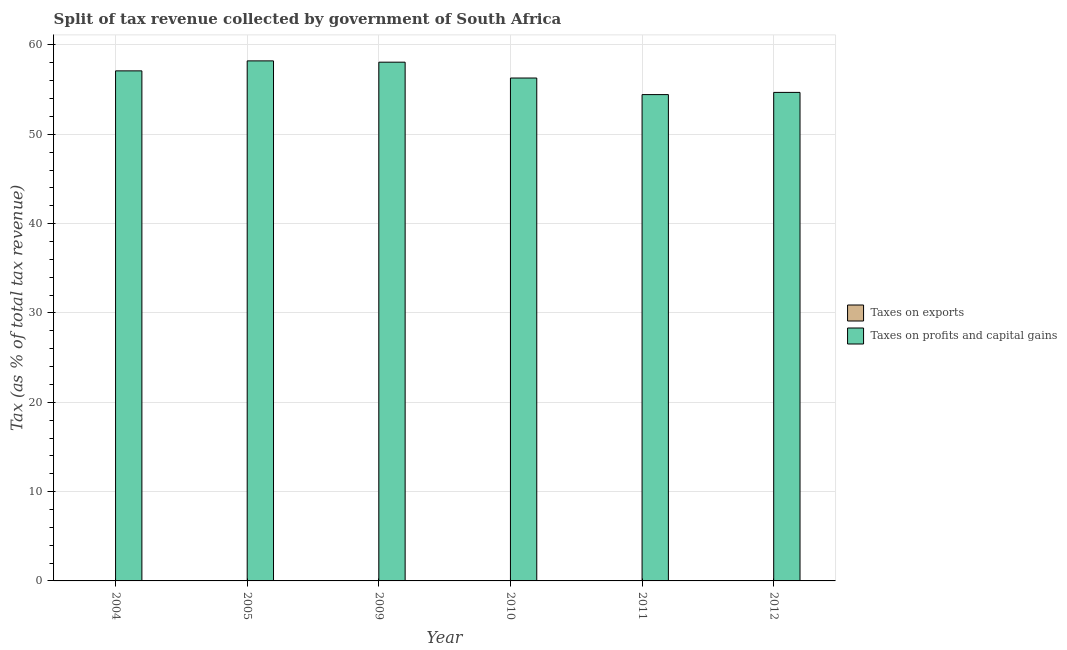How many different coloured bars are there?
Your response must be concise. 2. Are the number of bars per tick equal to the number of legend labels?
Your answer should be compact. Yes. Are the number of bars on each tick of the X-axis equal?
Your response must be concise. Yes. How many bars are there on the 2nd tick from the right?
Your response must be concise. 2. In how many cases, is the number of bars for a given year not equal to the number of legend labels?
Give a very brief answer. 0. What is the percentage of revenue obtained from taxes on profits and capital gains in 2010?
Provide a short and direct response. 56.3. Across all years, what is the maximum percentage of revenue obtained from taxes on profits and capital gains?
Give a very brief answer. 58.22. Across all years, what is the minimum percentage of revenue obtained from taxes on profits and capital gains?
Make the answer very short. 54.45. In which year was the percentage of revenue obtained from taxes on profits and capital gains maximum?
Your response must be concise. 2005. What is the total percentage of revenue obtained from taxes on exports in the graph?
Provide a succinct answer. 0.03. What is the difference between the percentage of revenue obtained from taxes on exports in 2004 and that in 2012?
Ensure brevity in your answer.  -0.01. What is the difference between the percentage of revenue obtained from taxes on profits and capital gains in 2012 and the percentage of revenue obtained from taxes on exports in 2010?
Keep it short and to the point. -1.61. What is the average percentage of revenue obtained from taxes on profits and capital gains per year?
Make the answer very short. 56.47. What is the ratio of the percentage of revenue obtained from taxes on profits and capital gains in 2009 to that in 2010?
Your answer should be compact. 1.03. What is the difference between the highest and the second highest percentage of revenue obtained from taxes on profits and capital gains?
Your response must be concise. 0.15. What is the difference between the highest and the lowest percentage of revenue obtained from taxes on exports?
Give a very brief answer. 0.01. In how many years, is the percentage of revenue obtained from taxes on exports greater than the average percentage of revenue obtained from taxes on exports taken over all years?
Your answer should be very brief. 4. What does the 1st bar from the left in 2009 represents?
Give a very brief answer. Taxes on exports. What does the 2nd bar from the right in 2004 represents?
Offer a terse response. Taxes on exports. How many years are there in the graph?
Provide a short and direct response. 6. What is the difference between two consecutive major ticks on the Y-axis?
Keep it short and to the point. 10. Does the graph contain any zero values?
Provide a short and direct response. No. Does the graph contain grids?
Your answer should be compact. Yes. How are the legend labels stacked?
Your answer should be compact. Vertical. What is the title of the graph?
Keep it short and to the point. Split of tax revenue collected by government of South Africa. What is the label or title of the Y-axis?
Offer a terse response. Tax (as % of total tax revenue). What is the Tax (as % of total tax revenue) of Taxes on exports in 2004?
Provide a succinct answer. 0. What is the Tax (as % of total tax revenue) of Taxes on profits and capital gains in 2004?
Offer a terse response. 57.1. What is the Tax (as % of total tax revenue) of Taxes on exports in 2005?
Offer a terse response. 0. What is the Tax (as % of total tax revenue) of Taxes on profits and capital gains in 2005?
Provide a short and direct response. 58.22. What is the Tax (as % of total tax revenue) of Taxes on exports in 2009?
Provide a succinct answer. 0.01. What is the Tax (as % of total tax revenue) of Taxes on profits and capital gains in 2009?
Ensure brevity in your answer.  58.08. What is the Tax (as % of total tax revenue) in Taxes on exports in 2010?
Your response must be concise. 0.01. What is the Tax (as % of total tax revenue) in Taxes on profits and capital gains in 2010?
Provide a short and direct response. 56.3. What is the Tax (as % of total tax revenue) of Taxes on exports in 2011?
Offer a very short reply. 0.01. What is the Tax (as % of total tax revenue) in Taxes on profits and capital gains in 2011?
Give a very brief answer. 54.45. What is the Tax (as % of total tax revenue) of Taxes on exports in 2012?
Your answer should be very brief. 0.01. What is the Tax (as % of total tax revenue) of Taxes on profits and capital gains in 2012?
Provide a short and direct response. 54.69. Across all years, what is the maximum Tax (as % of total tax revenue) of Taxes on exports?
Make the answer very short. 0.01. Across all years, what is the maximum Tax (as % of total tax revenue) of Taxes on profits and capital gains?
Provide a short and direct response. 58.22. Across all years, what is the minimum Tax (as % of total tax revenue) of Taxes on exports?
Your answer should be very brief. 0. Across all years, what is the minimum Tax (as % of total tax revenue) in Taxes on profits and capital gains?
Ensure brevity in your answer.  54.45. What is the total Tax (as % of total tax revenue) of Taxes on exports in the graph?
Your response must be concise. 0.03. What is the total Tax (as % of total tax revenue) in Taxes on profits and capital gains in the graph?
Ensure brevity in your answer.  338.84. What is the difference between the Tax (as % of total tax revenue) in Taxes on exports in 2004 and that in 2005?
Your response must be concise. 0. What is the difference between the Tax (as % of total tax revenue) in Taxes on profits and capital gains in 2004 and that in 2005?
Offer a very short reply. -1.12. What is the difference between the Tax (as % of total tax revenue) of Taxes on exports in 2004 and that in 2009?
Your answer should be very brief. -0.01. What is the difference between the Tax (as % of total tax revenue) of Taxes on profits and capital gains in 2004 and that in 2009?
Offer a very short reply. -0.97. What is the difference between the Tax (as % of total tax revenue) in Taxes on exports in 2004 and that in 2010?
Provide a succinct answer. -0.01. What is the difference between the Tax (as % of total tax revenue) in Taxes on profits and capital gains in 2004 and that in 2010?
Make the answer very short. 0.8. What is the difference between the Tax (as % of total tax revenue) of Taxes on exports in 2004 and that in 2011?
Your answer should be very brief. -0.01. What is the difference between the Tax (as % of total tax revenue) in Taxes on profits and capital gains in 2004 and that in 2011?
Provide a short and direct response. 2.66. What is the difference between the Tax (as % of total tax revenue) of Taxes on exports in 2004 and that in 2012?
Ensure brevity in your answer.  -0.01. What is the difference between the Tax (as % of total tax revenue) in Taxes on profits and capital gains in 2004 and that in 2012?
Ensure brevity in your answer.  2.41. What is the difference between the Tax (as % of total tax revenue) in Taxes on exports in 2005 and that in 2009?
Provide a succinct answer. -0.01. What is the difference between the Tax (as % of total tax revenue) in Taxes on profits and capital gains in 2005 and that in 2009?
Give a very brief answer. 0.15. What is the difference between the Tax (as % of total tax revenue) in Taxes on exports in 2005 and that in 2010?
Give a very brief answer. -0.01. What is the difference between the Tax (as % of total tax revenue) in Taxes on profits and capital gains in 2005 and that in 2010?
Offer a terse response. 1.92. What is the difference between the Tax (as % of total tax revenue) of Taxes on exports in 2005 and that in 2011?
Offer a very short reply. -0.01. What is the difference between the Tax (as % of total tax revenue) of Taxes on profits and capital gains in 2005 and that in 2011?
Make the answer very short. 3.78. What is the difference between the Tax (as % of total tax revenue) in Taxes on exports in 2005 and that in 2012?
Your answer should be very brief. -0.01. What is the difference between the Tax (as % of total tax revenue) in Taxes on profits and capital gains in 2005 and that in 2012?
Offer a very short reply. 3.53. What is the difference between the Tax (as % of total tax revenue) in Taxes on exports in 2009 and that in 2010?
Keep it short and to the point. -0. What is the difference between the Tax (as % of total tax revenue) in Taxes on profits and capital gains in 2009 and that in 2010?
Provide a short and direct response. 1.77. What is the difference between the Tax (as % of total tax revenue) in Taxes on exports in 2009 and that in 2011?
Ensure brevity in your answer.  -0. What is the difference between the Tax (as % of total tax revenue) of Taxes on profits and capital gains in 2009 and that in 2011?
Offer a very short reply. 3.63. What is the difference between the Tax (as % of total tax revenue) of Taxes on exports in 2009 and that in 2012?
Your response must be concise. -0. What is the difference between the Tax (as % of total tax revenue) in Taxes on profits and capital gains in 2009 and that in 2012?
Make the answer very short. 3.38. What is the difference between the Tax (as % of total tax revenue) of Taxes on exports in 2010 and that in 2011?
Your answer should be compact. 0. What is the difference between the Tax (as % of total tax revenue) in Taxes on profits and capital gains in 2010 and that in 2011?
Make the answer very short. 1.86. What is the difference between the Tax (as % of total tax revenue) in Taxes on exports in 2010 and that in 2012?
Your answer should be very brief. 0. What is the difference between the Tax (as % of total tax revenue) in Taxes on profits and capital gains in 2010 and that in 2012?
Make the answer very short. 1.61. What is the difference between the Tax (as % of total tax revenue) of Taxes on exports in 2011 and that in 2012?
Your answer should be compact. 0. What is the difference between the Tax (as % of total tax revenue) of Taxes on profits and capital gains in 2011 and that in 2012?
Your answer should be very brief. -0.25. What is the difference between the Tax (as % of total tax revenue) of Taxes on exports in 2004 and the Tax (as % of total tax revenue) of Taxes on profits and capital gains in 2005?
Offer a very short reply. -58.22. What is the difference between the Tax (as % of total tax revenue) of Taxes on exports in 2004 and the Tax (as % of total tax revenue) of Taxes on profits and capital gains in 2009?
Offer a terse response. -58.08. What is the difference between the Tax (as % of total tax revenue) of Taxes on exports in 2004 and the Tax (as % of total tax revenue) of Taxes on profits and capital gains in 2010?
Provide a short and direct response. -56.3. What is the difference between the Tax (as % of total tax revenue) of Taxes on exports in 2004 and the Tax (as % of total tax revenue) of Taxes on profits and capital gains in 2011?
Offer a terse response. -54.45. What is the difference between the Tax (as % of total tax revenue) of Taxes on exports in 2004 and the Tax (as % of total tax revenue) of Taxes on profits and capital gains in 2012?
Your answer should be compact. -54.69. What is the difference between the Tax (as % of total tax revenue) in Taxes on exports in 2005 and the Tax (as % of total tax revenue) in Taxes on profits and capital gains in 2009?
Provide a short and direct response. -58.08. What is the difference between the Tax (as % of total tax revenue) in Taxes on exports in 2005 and the Tax (as % of total tax revenue) in Taxes on profits and capital gains in 2010?
Offer a very short reply. -56.3. What is the difference between the Tax (as % of total tax revenue) of Taxes on exports in 2005 and the Tax (as % of total tax revenue) of Taxes on profits and capital gains in 2011?
Keep it short and to the point. -54.45. What is the difference between the Tax (as % of total tax revenue) of Taxes on exports in 2005 and the Tax (as % of total tax revenue) of Taxes on profits and capital gains in 2012?
Provide a succinct answer. -54.69. What is the difference between the Tax (as % of total tax revenue) in Taxes on exports in 2009 and the Tax (as % of total tax revenue) in Taxes on profits and capital gains in 2010?
Ensure brevity in your answer.  -56.3. What is the difference between the Tax (as % of total tax revenue) in Taxes on exports in 2009 and the Tax (as % of total tax revenue) in Taxes on profits and capital gains in 2011?
Provide a short and direct response. -54.44. What is the difference between the Tax (as % of total tax revenue) of Taxes on exports in 2009 and the Tax (as % of total tax revenue) of Taxes on profits and capital gains in 2012?
Give a very brief answer. -54.69. What is the difference between the Tax (as % of total tax revenue) of Taxes on exports in 2010 and the Tax (as % of total tax revenue) of Taxes on profits and capital gains in 2011?
Your answer should be compact. -54.44. What is the difference between the Tax (as % of total tax revenue) in Taxes on exports in 2010 and the Tax (as % of total tax revenue) in Taxes on profits and capital gains in 2012?
Make the answer very short. -54.68. What is the difference between the Tax (as % of total tax revenue) of Taxes on exports in 2011 and the Tax (as % of total tax revenue) of Taxes on profits and capital gains in 2012?
Give a very brief answer. -54.68. What is the average Tax (as % of total tax revenue) in Taxes on exports per year?
Your response must be concise. 0.01. What is the average Tax (as % of total tax revenue) in Taxes on profits and capital gains per year?
Your answer should be very brief. 56.47. In the year 2004, what is the difference between the Tax (as % of total tax revenue) of Taxes on exports and Tax (as % of total tax revenue) of Taxes on profits and capital gains?
Your answer should be very brief. -57.1. In the year 2005, what is the difference between the Tax (as % of total tax revenue) in Taxes on exports and Tax (as % of total tax revenue) in Taxes on profits and capital gains?
Make the answer very short. -58.22. In the year 2009, what is the difference between the Tax (as % of total tax revenue) in Taxes on exports and Tax (as % of total tax revenue) in Taxes on profits and capital gains?
Your answer should be compact. -58.07. In the year 2010, what is the difference between the Tax (as % of total tax revenue) in Taxes on exports and Tax (as % of total tax revenue) in Taxes on profits and capital gains?
Offer a very short reply. -56.29. In the year 2011, what is the difference between the Tax (as % of total tax revenue) in Taxes on exports and Tax (as % of total tax revenue) in Taxes on profits and capital gains?
Keep it short and to the point. -54.44. In the year 2012, what is the difference between the Tax (as % of total tax revenue) of Taxes on exports and Tax (as % of total tax revenue) of Taxes on profits and capital gains?
Your answer should be compact. -54.69. What is the ratio of the Tax (as % of total tax revenue) of Taxes on exports in 2004 to that in 2005?
Offer a very short reply. 1.18. What is the ratio of the Tax (as % of total tax revenue) of Taxes on profits and capital gains in 2004 to that in 2005?
Make the answer very short. 0.98. What is the ratio of the Tax (as % of total tax revenue) in Taxes on exports in 2004 to that in 2009?
Your answer should be compact. 0.05. What is the ratio of the Tax (as % of total tax revenue) in Taxes on profits and capital gains in 2004 to that in 2009?
Your answer should be very brief. 0.98. What is the ratio of the Tax (as % of total tax revenue) of Taxes on exports in 2004 to that in 2010?
Your answer should be compact. 0.03. What is the ratio of the Tax (as % of total tax revenue) in Taxes on profits and capital gains in 2004 to that in 2010?
Give a very brief answer. 1.01. What is the ratio of the Tax (as % of total tax revenue) in Taxes on exports in 2004 to that in 2011?
Your answer should be very brief. 0.03. What is the ratio of the Tax (as % of total tax revenue) of Taxes on profits and capital gains in 2004 to that in 2011?
Make the answer very short. 1.05. What is the ratio of the Tax (as % of total tax revenue) in Taxes on exports in 2004 to that in 2012?
Keep it short and to the point. 0.04. What is the ratio of the Tax (as % of total tax revenue) in Taxes on profits and capital gains in 2004 to that in 2012?
Your answer should be very brief. 1.04. What is the ratio of the Tax (as % of total tax revenue) of Taxes on exports in 2005 to that in 2009?
Provide a short and direct response. 0.04. What is the ratio of the Tax (as % of total tax revenue) in Taxes on exports in 2005 to that in 2010?
Your answer should be very brief. 0.02. What is the ratio of the Tax (as % of total tax revenue) of Taxes on profits and capital gains in 2005 to that in 2010?
Your response must be concise. 1.03. What is the ratio of the Tax (as % of total tax revenue) in Taxes on exports in 2005 to that in 2011?
Provide a short and direct response. 0.03. What is the ratio of the Tax (as % of total tax revenue) of Taxes on profits and capital gains in 2005 to that in 2011?
Make the answer very short. 1.07. What is the ratio of the Tax (as % of total tax revenue) of Taxes on exports in 2005 to that in 2012?
Provide a short and direct response. 0.04. What is the ratio of the Tax (as % of total tax revenue) of Taxes on profits and capital gains in 2005 to that in 2012?
Keep it short and to the point. 1.06. What is the ratio of the Tax (as % of total tax revenue) in Taxes on exports in 2009 to that in 2010?
Make the answer very short. 0.58. What is the ratio of the Tax (as % of total tax revenue) of Taxes on profits and capital gains in 2009 to that in 2010?
Keep it short and to the point. 1.03. What is the ratio of the Tax (as % of total tax revenue) in Taxes on exports in 2009 to that in 2011?
Ensure brevity in your answer.  0.7. What is the ratio of the Tax (as % of total tax revenue) of Taxes on profits and capital gains in 2009 to that in 2011?
Ensure brevity in your answer.  1.07. What is the ratio of the Tax (as % of total tax revenue) of Taxes on exports in 2009 to that in 2012?
Make the answer very short. 0.88. What is the ratio of the Tax (as % of total tax revenue) of Taxes on profits and capital gains in 2009 to that in 2012?
Provide a short and direct response. 1.06. What is the ratio of the Tax (as % of total tax revenue) in Taxes on exports in 2010 to that in 2011?
Make the answer very short. 1.21. What is the ratio of the Tax (as % of total tax revenue) in Taxes on profits and capital gains in 2010 to that in 2011?
Keep it short and to the point. 1.03. What is the ratio of the Tax (as % of total tax revenue) of Taxes on exports in 2010 to that in 2012?
Offer a very short reply. 1.54. What is the ratio of the Tax (as % of total tax revenue) of Taxes on profits and capital gains in 2010 to that in 2012?
Your answer should be compact. 1.03. What is the ratio of the Tax (as % of total tax revenue) of Taxes on exports in 2011 to that in 2012?
Offer a very short reply. 1.27. What is the difference between the highest and the second highest Tax (as % of total tax revenue) of Taxes on exports?
Provide a short and direct response. 0. What is the difference between the highest and the second highest Tax (as % of total tax revenue) in Taxes on profits and capital gains?
Give a very brief answer. 0.15. What is the difference between the highest and the lowest Tax (as % of total tax revenue) of Taxes on profits and capital gains?
Your response must be concise. 3.78. 